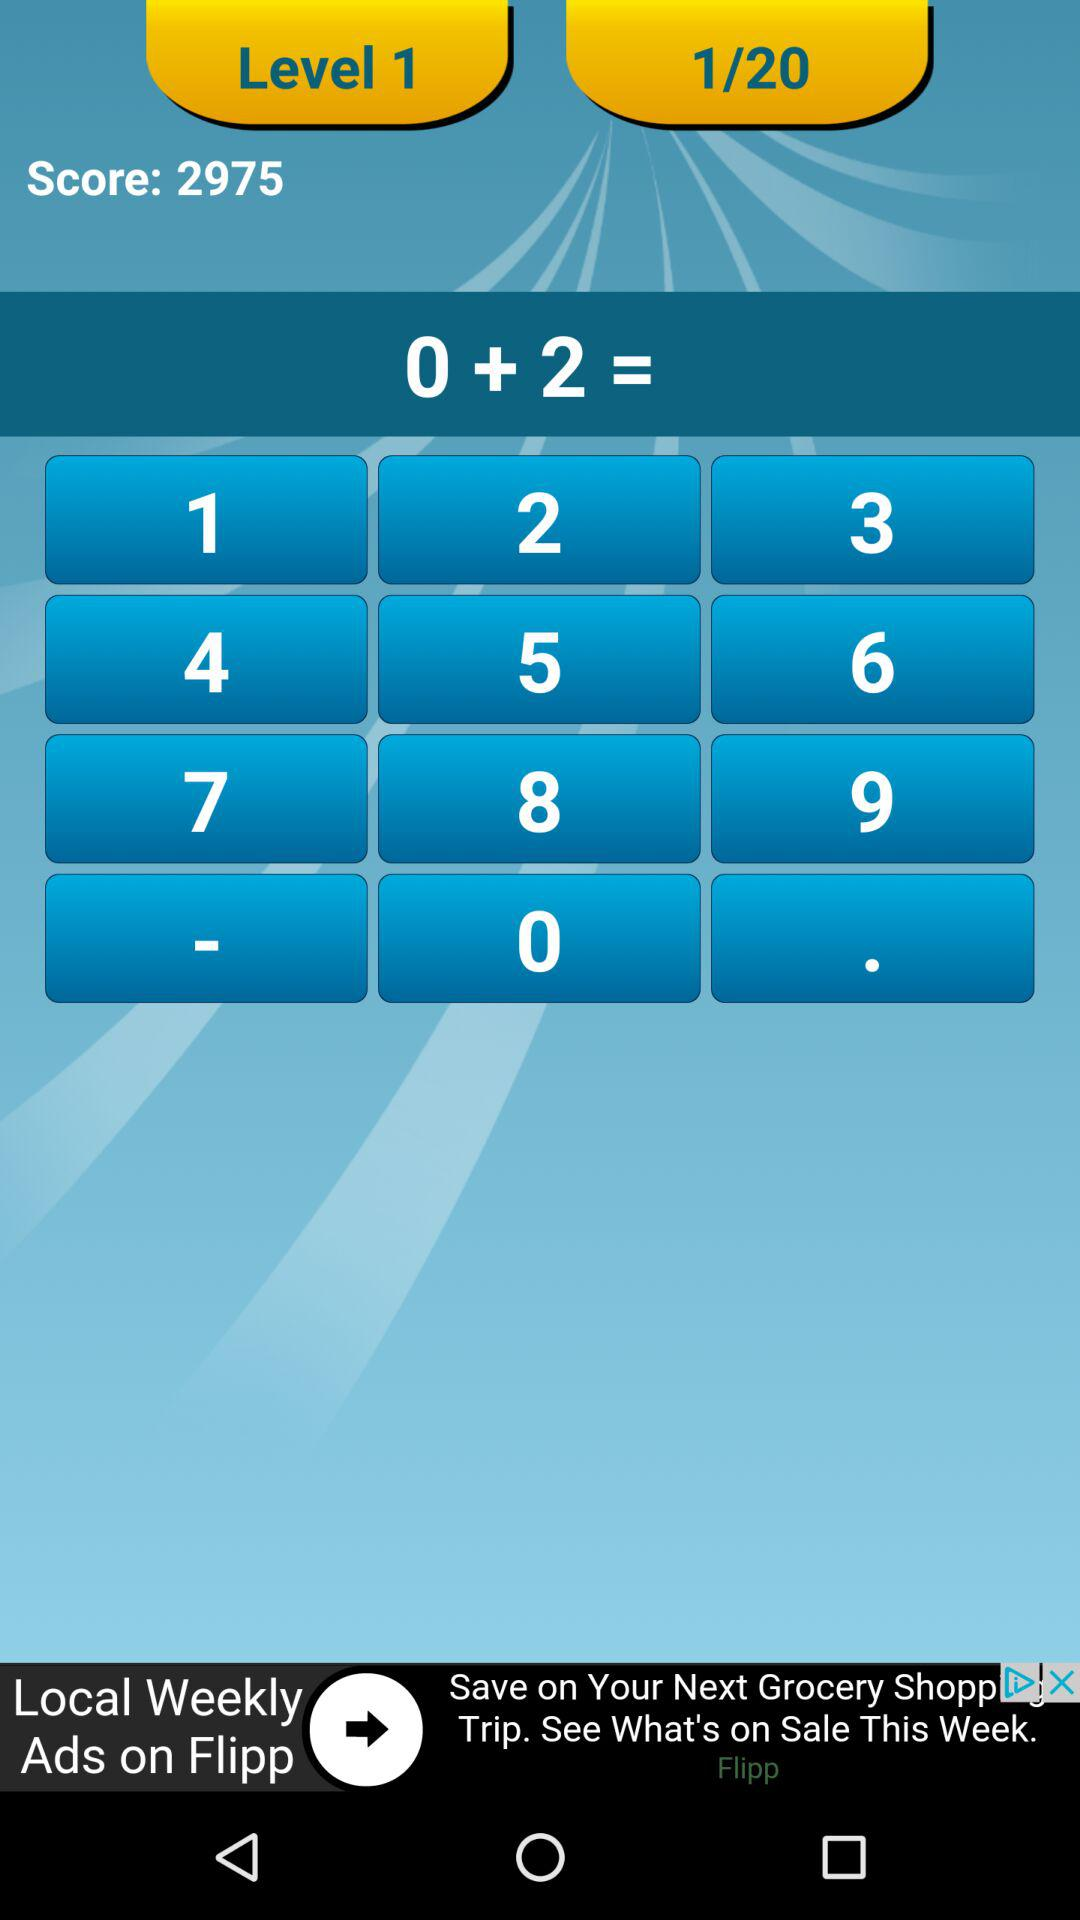At what level am I? You are at level 1. 